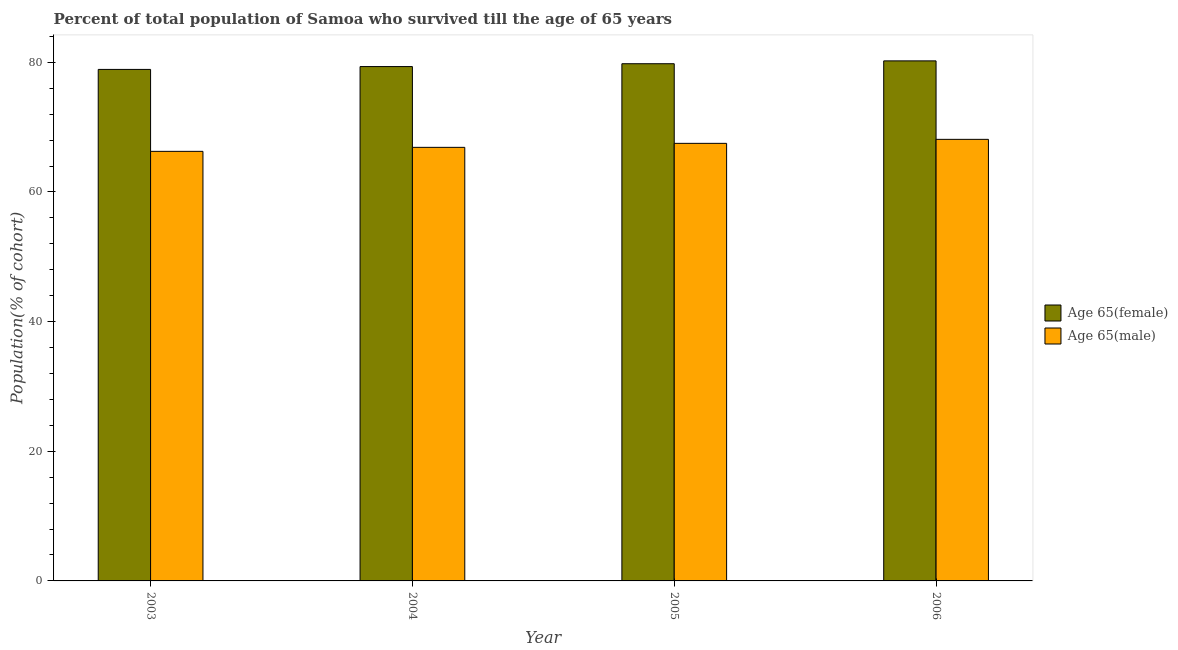How many different coloured bars are there?
Offer a very short reply. 2. How many groups of bars are there?
Offer a terse response. 4. Are the number of bars per tick equal to the number of legend labels?
Give a very brief answer. Yes. Are the number of bars on each tick of the X-axis equal?
Provide a succinct answer. Yes. What is the label of the 3rd group of bars from the left?
Give a very brief answer. 2005. What is the percentage of female population who survived till age of 65 in 2003?
Your answer should be very brief. 78.9. Across all years, what is the maximum percentage of female population who survived till age of 65?
Make the answer very short. 80.22. Across all years, what is the minimum percentage of male population who survived till age of 65?
Provide a succinct answer. 66.26. What is the total percentage of female population who survived till age of 65 in the graph?
Provide a short and direct response. 318.25. What is the difference between the percentage of female population who survived till age of 65 in 2003 and that in 2004?
Keep it short and to the point. -0.44. What is the difference between the percentage of male population who survived till age of 65 in 2005 and the percentage of female population who survived till age of 65 in 2004?
Your response must be concise. 0.62. What is the average percentage of male population who survived till age of 65 per year?
Keep it short and to the point. 67.19. In how many years, is the percentage of female population who survived till age of 65 greater than 48 %?
Provide a short and direct response. 4. What is the ratio of the percentage of male population who survived till age of 65 in 2003 to that in 2006?
Provide a short and direct response. 0.97. Is the percentage of female population who survived till age of 65 in 2004 less than that in 2005?
Keep it short and to the point. Yes. What is the difference between the highest and the second highest percentage of female population who survived till age of 65?
Provide a succinct answer. 0.44. What is the difference between the highest and the lowest percentage of male population who survived till age of 65?
Your answer should be very brief. 1.85. In how many years, is the percentage of male population who survived till age of 65 greater than the average percentage of male population who survived till age of 65 taken over all years?
Offer a very short reply. 2. Is the sum of the percentage of female population who survived till age of 65 in 2004 and 2005 greater than the maximum percentage of male population who survived till age of 65 across all years?
Offer a terse response. Yes. What does the 2nd bar from the left in 2003 represents?
Your answer should be compact. Age 65(male). What does the 1st bar from the right in 2003 represents?
Keep it short and to the point. Age 65(male). How many years are there in the graph?
Your answer should be very brief. 4. What is the difference between two consecutive major ticks on the Y-axis?
Provide a succinct answer. 20. Are the values on the major ticks of Y-axis written in scientific E-notation?
Ensure brevity in your answer.  No. Does the graph contain any zero values?
Your response must be concise. No. Does the graph contain grids?
Provide a short and direct response. No. How many legend labels are there?
Offer a terse response. 2. How are the legend labels stacked?
Keep it short and to the point. Vertical. What is the title of the graph?
Keep it short and to the point. Percent of total population of Samoa who survived till the age of 65 years. What is the label or title of the Y-axis?
Provide a succinct answer. Population(% of cohort). What is the Population(% of cohort) in Age 65(female) in 2003?
Your answer should be compact. 78.9. What is the Population(% of cohort) of Age 65(male) in 2003?
Your answer should be compact. 66.26. What is the Population(% of cohort) in Age 65(female) in 2004?
Your answer should be very brief. 79.34. What is the Population(% of cohort) in Age 65(male) in 2004?
Make the answer very short. 66.88. What is the Population(% of cohort) in Age 65(female) in 2005?
Make the answer very short. 79.78. What is the Population(% of cohort) in Age 65(male) in 2005?
Offer a very short reply. 67.5. What is the Population(% of cohort) of Age 65(female) in 2006?
Your answer should be very brief. 80.22. What is the Population(% of cohort) in Age 65(male) in 2006?
Provide a succinct answer. 68.12. Across all years, what is the maximum Population(% of cohort) in Age 65(female)?
Make the answer very short. 80.22. Across all years, what is the maximum Population(% of cohort) of Age 65(male)?
Ensure brevity in your answer.  68.12. Across all years, what is the minimum Population(% of cohort) of Age 65(female)?
Offer a very short reply. 78.9. Across all years, what is the minimum Population(% of cohort) of Age 65(male)?
Give a very brief answer. 66.26. What is the total Population(% of cohort) of Age 65(female) in the graph?
Your answer should be compact. 318.25. What is the total Population(% of cohort) of Age 65(male) in the graph?
Provide a succinct answer. 268.76. What is the difference between the Population(% of cohort) in Age 65(female) in 2003 and that in 2004?
Your answer should be compact. -0.44. What is the difference between the Population(% of cohort) of Age 65(male) in 2003 and that in 2004?
Provide a short and direct response. -0.62. What is the difference between the Population(% of cohort) of Age 65(female) in 2003 and that in 2005?
Offer a terse response. -0.88. What is the difference between the Population(% of cohort) of Age 65(male) in 2003 and that in 2005?
Give a very brief answer. -1.23. What is the difference between the Population(% of cohort) in Age 65(female) in 2003 and that in 2006?
Make the answer very short. -1.32. What is the difference between the Population(% of cohort) of Age 65(male) in 2003 and that in 2006?
Make the answer very short. -1.85. What is the difference between the Population(% of cohort) of Age 65(female) in 2004 and that in 2005?
Offer a very short reply. -0.44. What is the difference between the Population(% of cohort) in Age 65(male) in 2004 and that in 2005?
Provide a succinct answer. -0.62. What is the difference between the Population(% of cohort) of Age 65(female) in 2004 and that in 2006?
Provide a succinct answer. -0.88. What is the difference between the Population(% of cohort) of Age 65(male) in 2004 and that in 2006?
Offer a terse response. -1.23. What is the difference between the Population(% of cohort) in Age 65(female) in 2005 and that in 2006?
Your response must be concise. -0.44. What is the difference between the Population(% of cohort) in Age 65(male) in 2005 and that in 2006?
Your response must be concise. -0.62. What is the difference between the Population(% of cohort) in Age 65(female) in 2003 and the Population(% of cohort) in Age 65(male) in 2004?
Provide a short and direct response. 12.02. What is the difference between the Population(% of cohort) of Age 65(female) in 2003 and the Population(% of cohort) of Age 65(male) in 2005?
Keep it short and to the point. 11.4. What is the difference between the Population(% of cohort) in Age 65(female) in 2003 and the Population(% of cohort) in Age 65(male) in 2006?
Your response must be concise. 10.79. What is the difference between the Population(% of cohort) in Age 65(female) in 2004 and the Population(% of cohort) in Age 65(male) in 2005?
Your response must be concise. 11.84. What is the difference between the Population(% of cohort) in Age 65(female) in 2004 and the Population(% of cohort) in Age 65(male) in 2006?
Your answer should be compact. 11.23. What is the difference between the Population(% of cohort) in Age 65(female) in 2005 and the Population(% of cohort) in Age 65(male) in 2006?
Your answer should be very brief. 11.67. What is the average Population(% of cohort) of Age 65(female) per year?
Offer a terse response. 79.56. What is the average Population(% of cohort) of Age 65(male) per year?
Give a very brief answer. 67.19. In the year 2003, what is the difference between the Population(% of cohort) of Age 65(female) and Population(% of cohort) of Age 65(male)?
Provide a short and direct response. 12.64. In the year 2004, what is the difference between the Population(% of cohort) of Age 65(female) and Population(% of cohort) of Age 65(male)?
Your response must be concise. 12.46. In the year 2005, what is the difference between the Population(% of cohort) in Age 65(female) and Population(% of cohort) in Age 65(male)?
Keep it short and to the point. 12.28. In the year 2006, what is the difference between the Population(% of cohort) in Age 65(female) and Population(% of cohort) in Age 65(male)?
Provide a succinct answer. 12.11. What is the ratio of the Population(% of cohort) of Age 65(male) in 2003 to that in 2004?
Your answer should be compact. 0.99. What is the ratio of the Population(% of cohort) of Age 65(female) in 2003 to that in 2005?
Ensure brevity in your answer.  0.99. What is the ratio of the Population(% of cohort) of Age 65(male) in 2003 to that in 2005?
Offer a terse response. 0.98. What is the ratio of the Population(% of cohort) of Age 65(female) in 2003 to that in 2006?
Your answer should be compact. 0.98. What is the ratio of the Population(% of cohort) of Age 65(male) in 2003 to that in 2006?
Provide a succinct answer. 0.97. What is the ratio of the Population(% of cohort) in Age 65(female) in 2004 to that in 2005?
Offer a very short reply. 0.99. What is the ratio of the Population(% of cohort) of Age 65(male) in 2004 to that in 2005?
Keep it short and to the point. 0.99. What is the ratio of the Population(% of cohort) of Age 65(female) in 2004 to that in 2006?
Keep it short and to the point. 0.99. What is the ratio of the Population(% of cohort) of Age 65(male) in 2004 to that in 2006?
Your answer should be very brief. 0.98. What is the ratio of the Population(% of cohort) in Age 65(female) in 2005 to that in 2006?
Your answer should be compact. 0.99. What is the ratio of the Population(% of cohort) in Age 65(male) in 2005 to that in 2006?
Offer a terse response. 0.99. What is the difference between the highest and the second highest Population(% of cohort) of Age 65(female)?
Offer a terse response. 0.44. What is the difference between the highest and the second highest Population(% of cohort) of Age 65(male)?
Give a very brief answer. 0.62. What is the difference between the highest and the lowest Population(% of cohort) in Age 65(female)?
Provide a succinct answer. 1.32. What is the difference between the highest and the lowest Population(% of cohort) of Age 65(male)?
Keep it short and to the point. 1.85. 